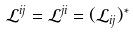Convert formula to latex. <formula><loc_0><loc_0><loc_500><loc_500>\mathcal { L } ^ { i j } = \mathcal { L } ^ { j i } = ( \mathcal { L } _ { i j } ) ^ { \ast }</formula> 